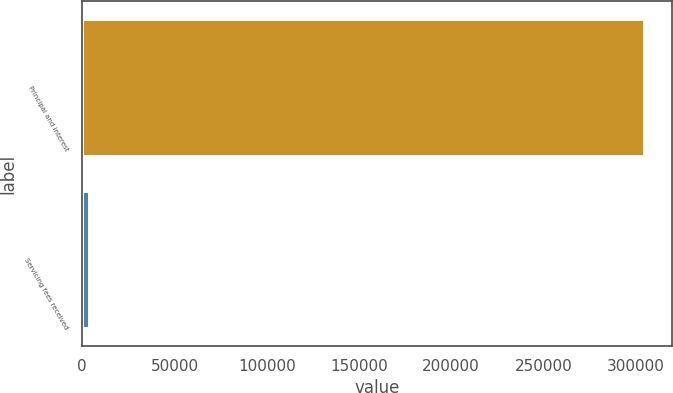Convert chart. <chart><loc_0><loc_0><loc_500><loc_500><bar_chart><fcel>Principal and interest<fcel>Servicing fees received<nl><fcel>304448<fcel>3480<nl></chart> 